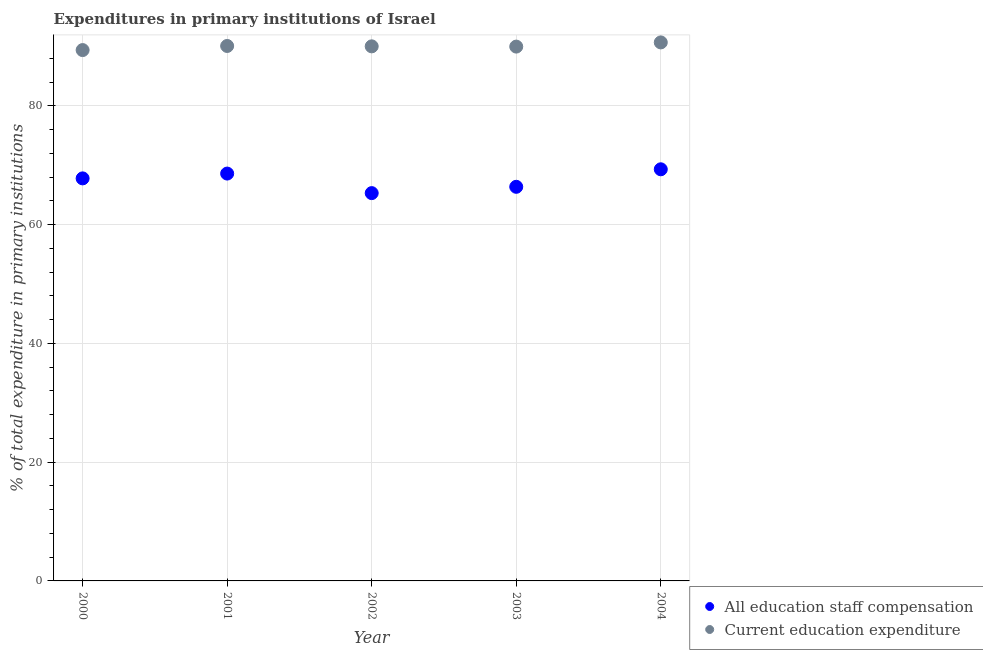What is the expenditure in education in 2003?
Provide a succinct answer. 89.99. Across all years, what is the maximum expenditure in education?
Provide a succinct answer. 90.7. Across all years, what is the minimum expenditure in education?
Provide a short and direct response. 89.41. In which year was the expenditure in education maximum?
Offer a terse response. 2004. What is the total expenditure in education in the graph?
Offer a terse response. 450.23. What is the difference between the expenditure in education in 2001 and that in 2003?
Offer a very short reply. 0.11. What is the difference between the expenditure in staff compensation in 2000 and the expenditure in education in 2004?
Make the answer very short. -22.9. What is the average expenditure in education per year?
Your answer should be very brief. 90.05. In the year 2003, what is the difference between the expenditure in staff compensation and expenditure in education?
Make the answer very short. -23.61. What is the ratio of the expenditure in staff compensation in 2002 to that in 2003?
Your response must be concise. 0.98. Is the expenditure in education in 2002 less than that in 2003?
Offer a very short reply. No. What is the difference between the highest and the second highest expenditure in education?
Keep it short and to the point. 0.6. What is the difference between the highest and the lowest expenditure in education?
Provide a short and direct response. 1.29. In how many years, is the expenditure in education greater than the average expenditure in education taken over all years?
Give a very brief answer. 2. Is the sum of the expenditure in education in 2000 and 2001 greater than the maximum expenditure in staff compensation across all years?
Your answer should be very brief. Yes. Does the expenditure in education monotonically increase over the years?
Your answer should be compact. No. Is the expenditure in staff compensation strictly greater than the expenditure in education over the years?
Make the answer very short. No. How many dotlines are there?
Offer a very short reply. 2. Are the values on the major ticks of Y-axis written in scientific E-notation?
Offer a very short reply. No. Does the graph contain grids?
Ensure brevity in your answer.  Yes. How are the legend labels stacked?
Provide a short and direct response. Vertical. What is the title of the graph?
Provide a succinct answer. Expenditures in primary institutions of Israel. What is the label or title of the Y-axis?
Provide a short and direct response. % of total expenditure in primary institutions. What is the % of total expenditure in primary institutions of All education staff compensation in 2000?
Offer a very short reply. 67.8. What is the % of total expenditure in primary institutions in Current education expenditure in 2000?
Keep it short and to the point. 89.41. What is the % of total expenditure in primary institutions in All education staff compensation in 2001?
Ensure brevity in your answer.  68.61. What is the % of total expenditure in primary institutions in Current education expenditure in 2001?
Your answer should be very brief. 90.1. What is the % of total expenditure in primary institutions of All education staff compensation in 2002?
Offer a terse response. 65.31. What is the % of total expenditure in primary institutions in Current education expenditure in 2002?
Your answer should be very brief. 90.03. What is the % of total expenditure in primary institutions of All education staff compensation in 2003?
Keep it short and to the point. 66.38. What is the % of total expenditure in primary institutions of Current education expenditure in 2003?
Provide a succinct answer. 89.99. What is the % of total expenditure in primary institutions of All education staff compensation in 2004?
Offer a terse response. 69.33. What is the % of total expenditure in primary institutions in Current education expenditure in 2004?
Keep it short and to the point. 90.7. Across all years, what is the maximum % of total expenditure in primary institutions of All education staff compensation?
Your answer should be compact. 69.33. Across all years, what is the maximum % of total expenditure in primary institutions in Current education expenditure?
Keep it short and to the point. 90.7. Across all years, what is the minimum % of total expenditure in primary institutions in All education staff compensation?
Provide a succinct answer. 65.31. Across all years, what is the minimum % of total expenditure in primary institutions of Current education expenditure?
Your answer should be very brief. 89.41. What is the total % of total expenditure in primary institutions of All education staff compensation in the graph?
Your answer should be very brief. 337.42. What is the total % of total expenditure in primary institutions in Current education expenditure in the graph?
Make the answer very short. 450.23. What is the difference between the % of total expenditure in primary institutions in All education staff compensation in 2000 and that in 2001?
Your response must be concise. -0.81. What is the difference between the % of total expenditure in primary institutions of Current education expenditure in 2000 and that in 2001?
Make the answer very short. -0.69. What is the difference between the % of total expenditure in primary institutions of All education staff compensation in 2000 and that in 2002?
Give a very brief answer. 2.48. What is the difference between the % of total expenditure in primary institutions in Current education expenditure in 2000 and that in 2002?
Keep it short and to the point. -0.63. What is the difference between the % of total expenditure in primary institutions in All education staff compensation in 2000 and that in 2003?
Provide a succinct answer. 1.42. What is the difference between the % of total expenditure in primary institutions in Current education expenditure in 2000 and that in 2003?
Your answer should be compact. -0.59. What is the difference between the % of total expenditure in primary institutions of All education staff compensation in 2000 and that in 2004?
Provide a succinct answer. -1.53. What is the difference between the % of total expenditure in primary institutions of Current education expenditure in 2000 and that in 2004?
Provide a succinct answer. -1.29. What is the difference between the % of total expenditure in primary institutions of All education staff compensation in 2001 and that in 2002?
Your answer should be compact. 3.29. What is the difference between the % of total expenditure in primary institutions in Current education expenditure in 2001 and that in 2002?
Offer a very short reply. 0.06. What is the difference between the % of total expenditure in primary institutions of All education staff compensation in 2001 and that in 2003?
Provide a succinct answer. 2.23. What is the difference between the % of total expenditure in primary institutions in Current education expenditure in 2001 and that in 2003?
Give a very brief answer. 0.11. What is the difference between the % of total expenditure in primary institutions of All education staff compensation in 2001 and that in 2004?
Your answer should be very brief. -0.72. What is the difference between the % of total expenditure in primary institutions in Current education expenditure in 2001 and that in 2004?
Offer a terse response. -0.6. What is the difference between the % of total expenditure in primary institutions in All education staff compensation in 2002 and that in 2003?
Ensure brevity in your answer.  -1.06. What is the difference between the % of total expenditure in primary institutions in Current education expenditure in 2002 and that in 2003?
Ensure brevity in your answer.  0.04. What is the difference between the % of total expenditure in primary institutions in All education staff compensation in 2002 and that in 2004?
Your answer should be compact. -4.01. What is the difference between the % of total expenditure in primary institutions in Current education expenditure in 2002 and that in 2004?
Keep it short and to the point. -0.66. What is the difference between the % of total expenditure in primary institutions of All education staff compensation in 2003 and that in 2004?
Your response must be concise. -2.95. What is the difference between the % of total expenditure in primary institutions in Current education expenditure in 2003 and that in 2004?
Keep it short and to the point. -0.71. What is the difference between the % of total expenditure in primary institutions in All education staff compensation in 2000 and the % of total expenditure in primary institutions in Current education expenditure in 2001?
Offer a very short reply. -22.3. What is the difference between the % of total expenditure in primary institutions of All education staff compensation in 2000 and the % of total expenditure in primary institutions of Current education expenditure in 2002?
Offer a very short reply. -22.24. What is the difference between the % of total expenditure in primary institutions of All education staff compensation in 2000 and the % of total expenditure in primary institutions of Current education expenditure in 2003?
Offer a very short reply. -22.19. What is the difference between the % of total expenditure in primary institutions in All education staff compensation in 2000 and the % of total expenditure in primary institutions in Current education expenditure in 2004?
Your answer should be very brief. -22.9. What is the difference between the % of total expenditure in primary institutions in All education staff compensation in 2001 and the % of total expenditure in primary institutions in Current education expenditure in 2002?
Your answer should be very brief. -21.43. What is the difference between the % of total expenditure in primary institutions in All education staff compensation in 2001 and the % of total expenditure in primary institutions in Current education expenditure in 2003?
Make the answer very short. -21.39. What is the difference between the % of total expenditure in primary institutions in All education staff compensation in 2001 and the % of total expenditure in primary institutions in Current education expenditure in 2004?
Provide a succinct answer. -22.09. What is the difference between the % of total expenditure in primary institutions of All education staff compensation in 2002 and the % of total expenditure in primary institutions of Current education expenditure in 2003?
Your answer should be very brief. -24.68. What is the difference between the % of total expenditure in primary institutions in All education staff compensation in 2002 and the % of total expenditure in primary institutions in Current education expenditure in 2004?
Keep it short and to the point. -25.38. What is the difference between the % of total expenditure in primary institutions of All education staff compensation in 2003 and the % of total expenditure in primary institutions of Current education expenditure in 2004?
Give a very brief answer. -24.32. What is the average % of total expenditure in primary institutions in All education staff compensation per year?
Keep it short and to the point. 67.48. What is the average % of total expenditure in primary institutions in Current education expenditure per year?
Your answer should be very brief. 90.05. In the year 2000, what is the difference between the % of total expenditure in primary institutions in All education staff compensation and % of total expenditure in primary institutions in Current education expenditure?
Provide a succinct answer. -21.61. In the year 2001, what is the difference between the % of total expenditure in primary institutions of All education staff compensation and % of total expenditure in primary institutions of Current education expenditure?
Keep it short and to the point. -21.49. In the year 2002, what is the difference between the % of total expenditure in primary institutions in All education staff compensation and % of total expenditure in primary institutions in Current education expenditure?
Offer a very short reply. -24.72. In the year 2003, what is the difference between the % of total expenditure in primary institutions in All education staff compensation and % of total expenditure in primary institutions in Current education expenditure?
Keep it short and to the point. -23.61. In the year 2004, what is the difference between the % of total expenditure in primary institutions in All education staff compensation and % of total expenditure in primary institutions in Current education expenditure?
Your answer should be compact. -21.37. What is the ratio of the % of total expenditure in primary institutions in All education staff compensation in 2000 to that in 2001?
Offer a terse response. 0.99. What is the ratio of the % of total expenditure in primary institutions of Current education expenditure in 2000 to that in 2001?
Your response must be concise. 0.99. What is the ratio of the % of total expenditure in primary institutions of All education staff compensation in 2000 to that in 2002?
Provide a short and direct response. 1.04. What is the ratio of the % of total expenditure in primary institutions in Current education expenditure in 2000 to that in 2002?
Your response must be concise. 0.99. What is the ratio of the % of total expenditure in primary institutions in All education staff compensation in 2000 to that in 2003?
Provide a succinct answer. 1.02. What is the ratio of the % of total expenditure in primary institutions of All education staff compensation in 2000 to that in 2004?
Keep it short and to the point. 0.98. What is the ratio of the % of total expenditure in primary institutions of Current education expenditure in 2000 to that in 2004?
Keep it short and to the point. 0.99. What is the ratio of the % of total expenditure in primary institutions of All education staff compensation in 2001 to that in 2002?
Your response must be concise. 1.05. What is the ratio of the % of total expenditure in primary institutions in Current education expenditure in 2001 to that in 2002?
Offer a very short reply. 1. What is the ratio of the % of total expenditure in primary institutions of All education staff compensation in 2001 to that in 2003?
Ensure brevity in your answer.  1.03. What is the ratio of the % of total expenditure in primary institutions in All education staff compensation in 2001 to that in 2004?
Keep it short and to the point. 0.99. What is the ratio of the % of total expenditure in primary institutions of Current education expenditure in 2002 to that in 2003?
Your answer should be very brief. 1. What is the ratio of the % of total expenditure in primary institutions in All education staff compensation in 2002 to that in 2004?
Your answer should be very brief. 0.94. What is the ratio of the % of total expenditure in primary institutions of All education staff compensation in 2003 to that in 2004?
Your response must be concise. 0.96. What is the ratio of the % of total expenditure in primary institutions of Current education expenditure in 2003 to that in 2004?
Ensure brevity in your answer.  0.99. What is the difference between the highest and the second highest % of total expenditure in primary institutions in All education staff compensation?
Provide a succinct answer. 0.72. What is the difference between the highest and the second highest % of total expenditure in primary institutions in Current education expenditure?
Provide a succinct answer. 0.6. What is the difference between the highest and the lowest % of total expenditure in primary institutions in All education staff compensation?
Provide a succinct answer. 4.01. What is the difference between the highest and the lowest % of total expenditure in primary institutions of Current education expenditure?
Your response must be concise. 1.29. 